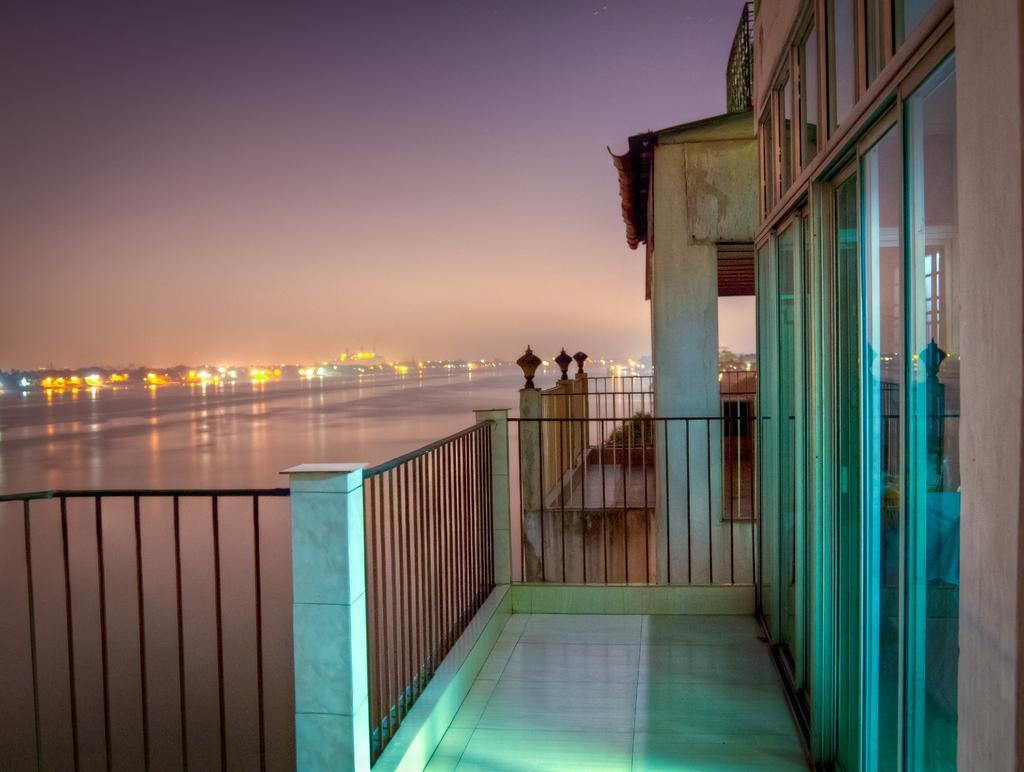In one or two sentences, can you explain what this image depicts? In the foreground of this image, there is floor, railing and the glass wall of a building. Behind it, it seems like there is another building. In the background, there is water, lights and the sky. 